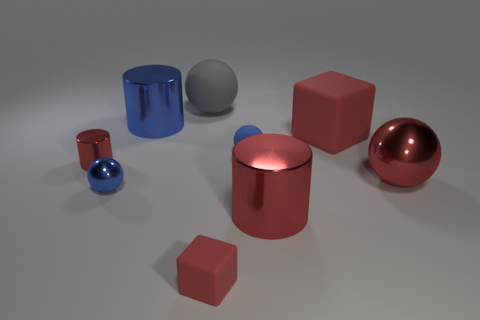What shape is the big blue object?
Your response must be concise. Cylinder. Is there a small rubber thing that has the same color as the big block?
Your response must be concise. Yes. How many tiny objects are gray metallic cylinders or red cubes?
Provide a succinct answer. 1. Does the tiny red object to the right of the big rubber ball have the same material as the large gray sphere?
Your answer should be very brief. Yes. The red metal object that is left of the large cylinder that is on the left side of the ball behind the large block is what shape?
Your response must be concise. Cylinder. What number of gray objects are big rubber cubes or rubber blocks?
Give a very brief answer. 0. Is the number of big cylinders in front of the small blue metal object the same as the number of big metallic cylinders behind the small cylinder?
Your response must be concise. Yes. There is a blue thing behind the tiny blue rubber sphere; is its shape the same as the red metallic thing on the left side of the tiny blue rubber ball?
Your answer should be very brief. Yes. There is another blue thing that is made of the same material as the big blue object; what is its shape?
Make the answer very short. Sphere. Are there an equal number of large rubber cubes that are behind the large red metal cylinder and big red spheres?
Provide a short and direct response. Yes. 